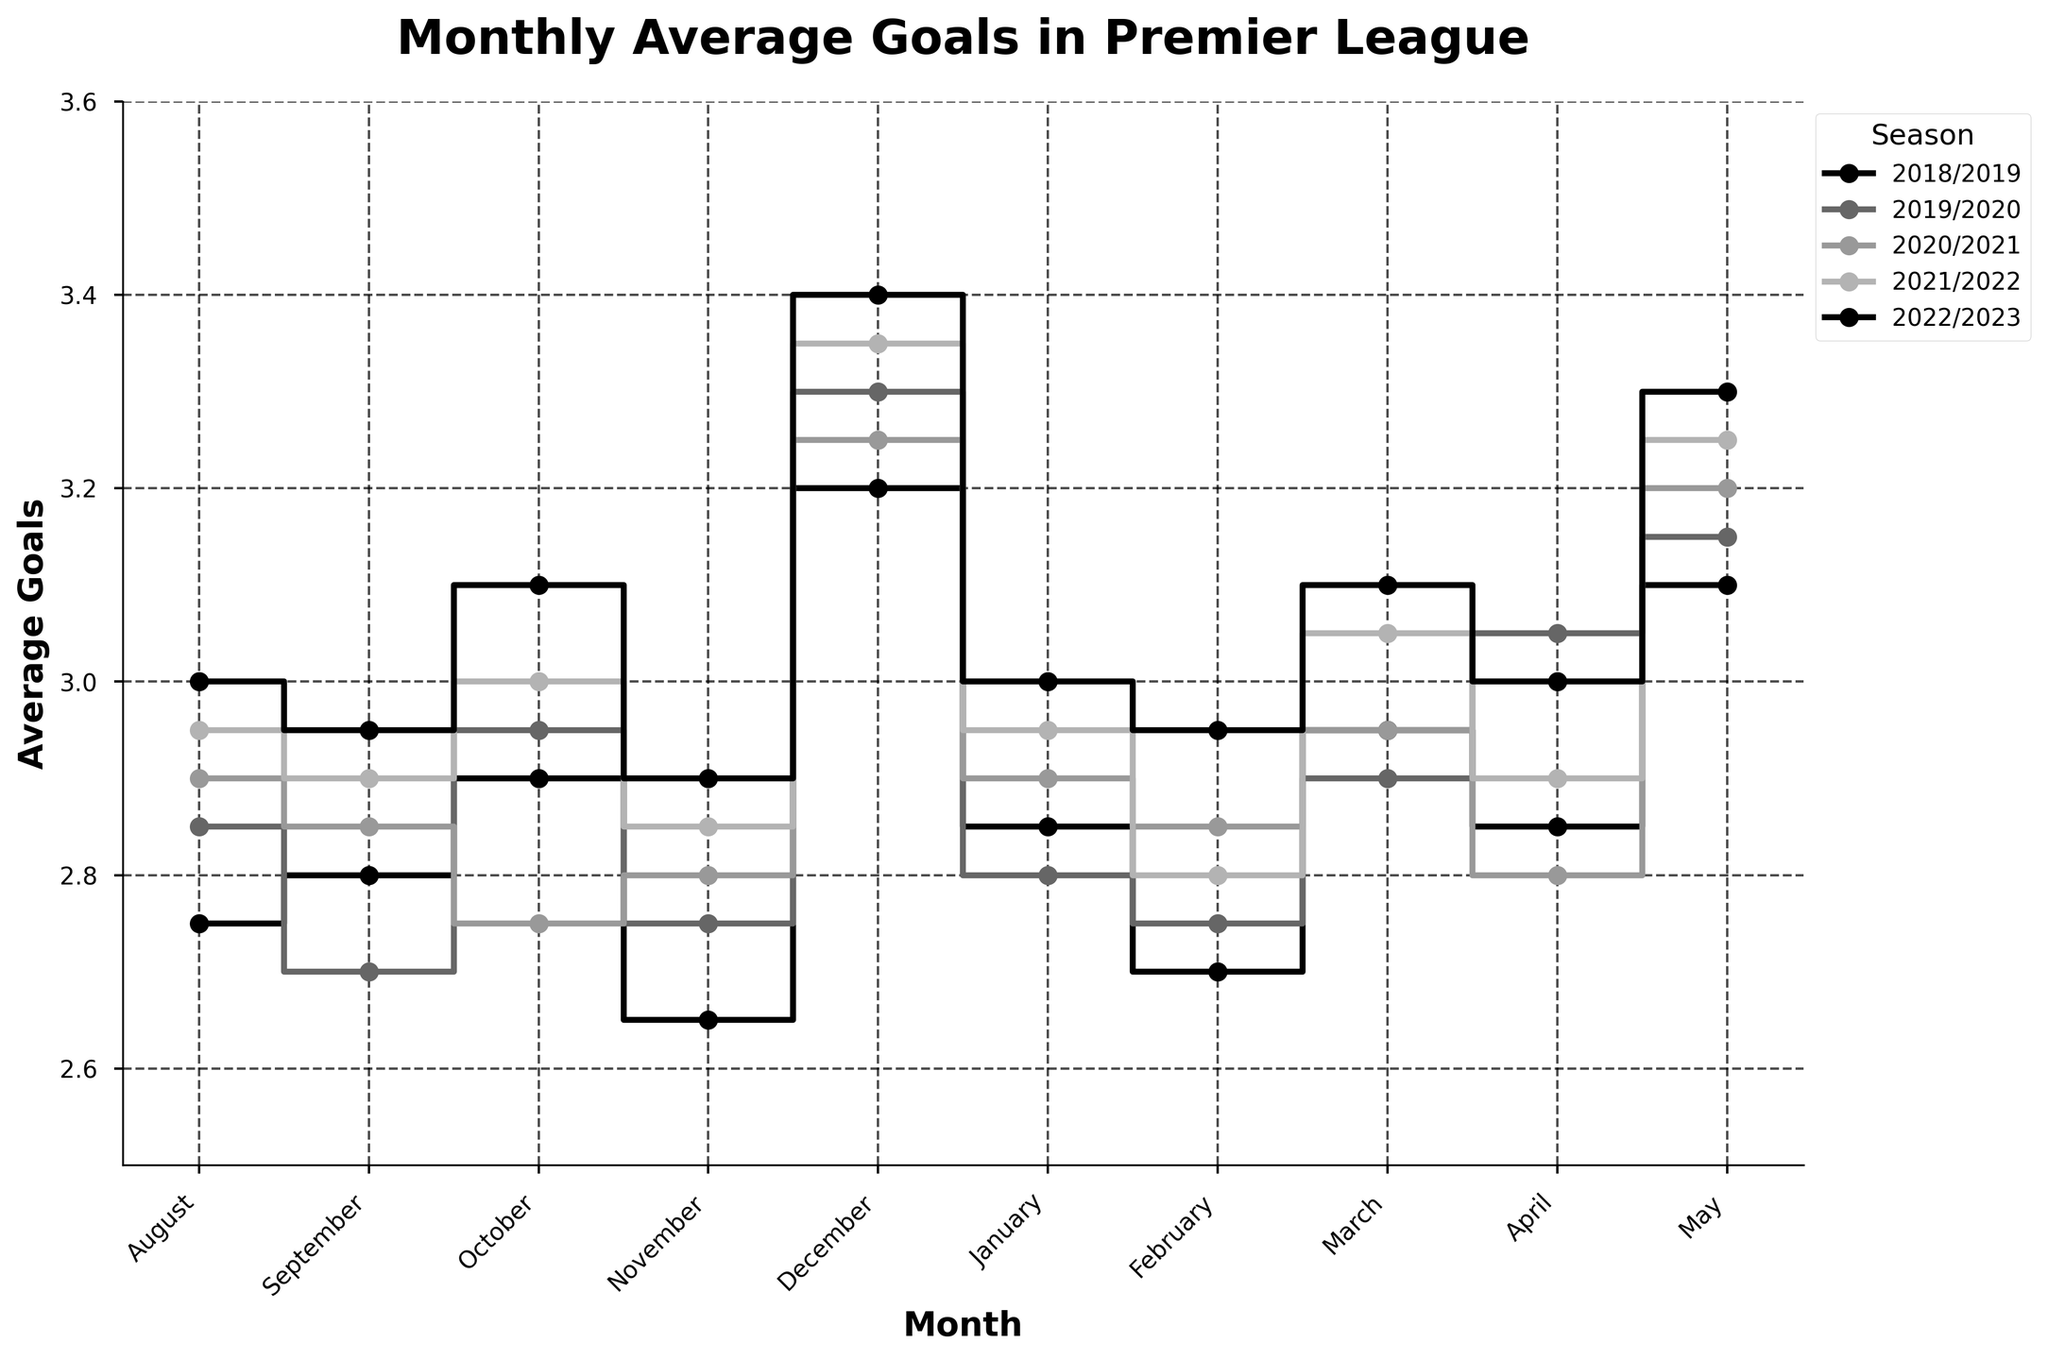What is the title of the plot? The title is usually located at the top of the plot. Here, it is stated clearly.
Answer: Monthly Average Goals in Premier League Which month consistently shows the highest average goals across all seasons? By comparing the average goals for each month across all seasons, December consistently shows the highest number.
Answer: December In which season did August have the lowest average goals? Examine the average goals in August for each season. The 2019/2020 season has the lowest value at 2.85.
Answer: 2019/2020 What is the range of average goals in the 2022/2023 season? Look at the highest and lowest average goals in the 2022/2023 season. The highest is 3.40 in December and the lowest is 2.95 in September and February.
Answer: 2.95 to 3.40 Which season has the most fluctuations in average goals per month? To find the most fluctuation, identify the season with the widest range between the lowest and highest points. The 2022/2023 season shows the highest range from 2.95 to 3.40.
Answer: 2022/2023 Are there any months where the average goals remained within a close range across all seasons? Look for months where the differences in average goals are minimal across seasons. February has relatively close values between 2.70 and 2.95.
Answer: February Which season had the highest average goals in May? Compare the average goals in May for all seasons. The 2022/2023 season has the highest value at 3.30.
Answer: 2022/2023 Which months in the 2021/2022 season had the highest and lowest average goals? Identify the highest and lowest points in the 2021/2022 season. December is the highest with 3.35, and February is the lowest with 2.80.
Answer: December and February How does the average of goals in October 2020/2021 compare to October 2021/2022? Compare the values for October across the two specified seasons. The average goals for October 2020/2021 are 2.75, while for October 2021/2022 they are 3.00, so 2021/2022 has higher average goals by 0.25.
Answer: October 2021/2022 is higher by 0.25 